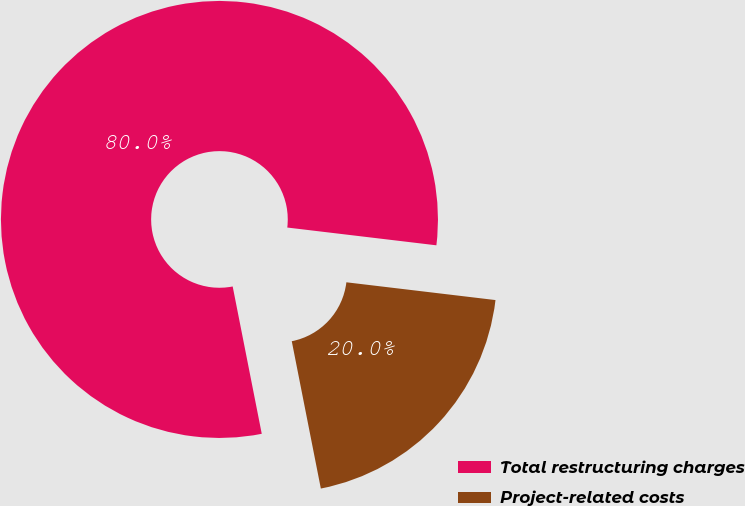Convert chart to OTSL. <chart><loc_0><loc_0><loc_500><loc_500><pie_chart><fcel>Total restructuring charges<fcel>Project-related costs<nl><fcel>79.99%<fcel>20.01%<nl></chart> 